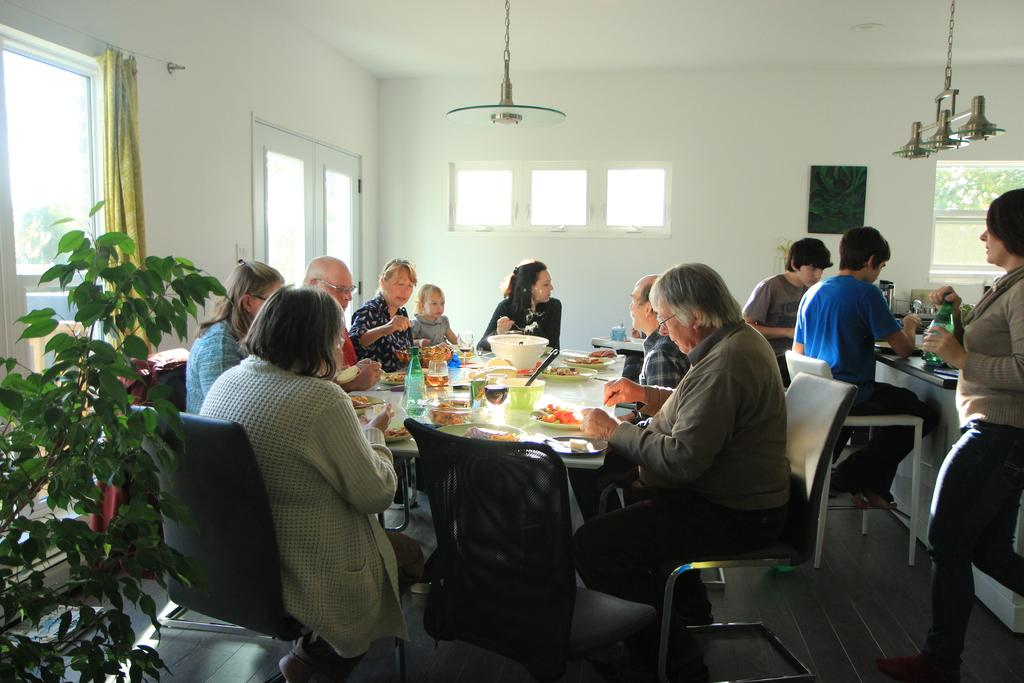What are the people in the image doing? There are persons sitting on chairs in the image. What is on the table in the image? There are eatable items on a table in the image. What can be seen in the background of the image? There is a wall, a window, a curtain, and a small plant in the background of the image. What channel is the creator reacting to in the image? There is no channel or creator present in the image; it features persons sitting on chairs and a table with eatable items. 